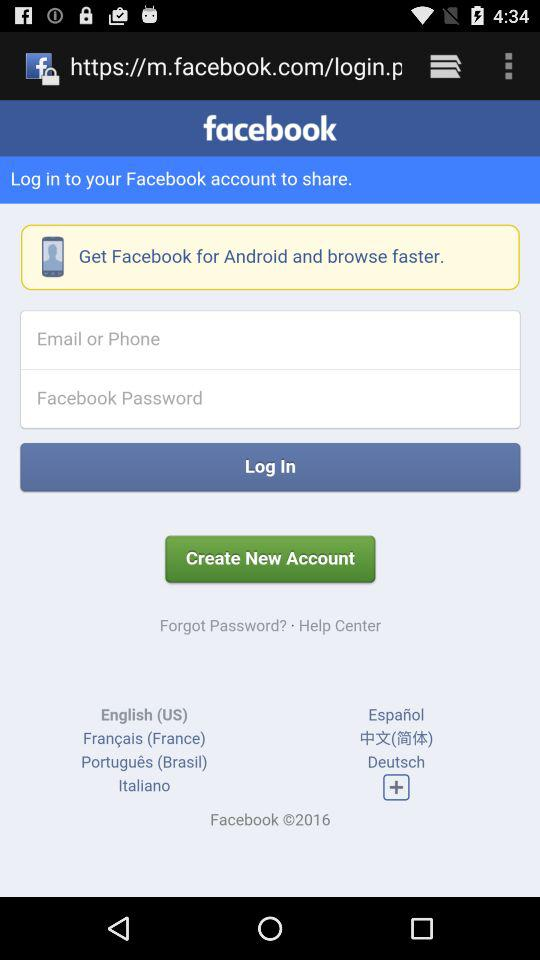Through what application can we log in? You can log in through "facebook". 